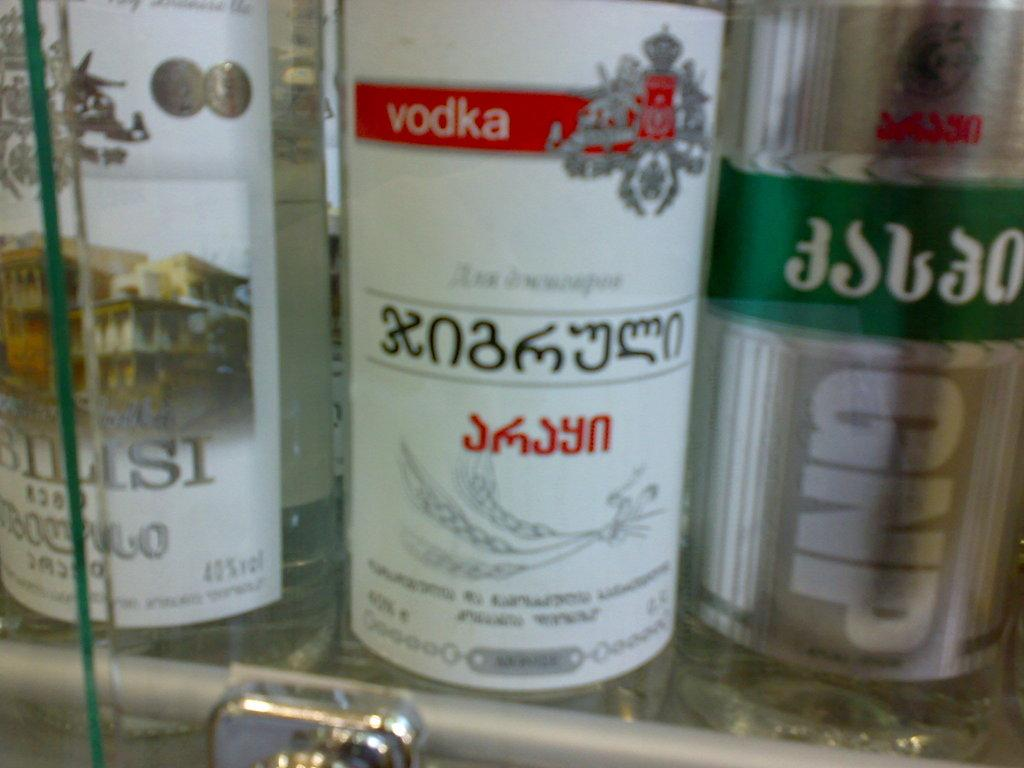What type of beverage containers are visible in the image? There are wine bottles in the image. Where are the wine bottles located? The wine bottles are kept on a shelf. Can you read any labels on the wine bottles? The label on one of the wine bottles says "Vodka". How many pockets are visible on the wine bottles in the image? There are no pockets visible on the wine bottles in the image, as wine bottles do not have pockets. 